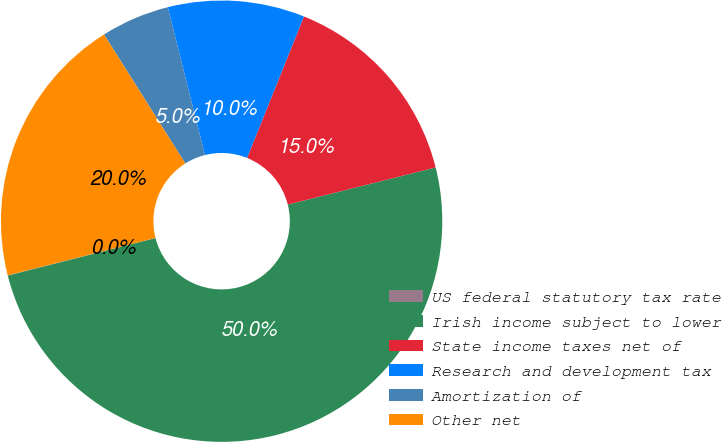Convert chart to OTSL. <chart><loc_0><loc_0><loc_500><loc_500><pie_chart><fcel>US federal statutory tax rate<fcel>Irish income subject to lower<fcel>State income taxes net of<fcel>Research and development tax<fcel>Amortization of<fcel>Other net<nl><fcel>0.02%<fcel>49.95%<fcel>15.0%<fcel>10.01%<fcel>5.02%<fcel>20.0%<nl></chart> 